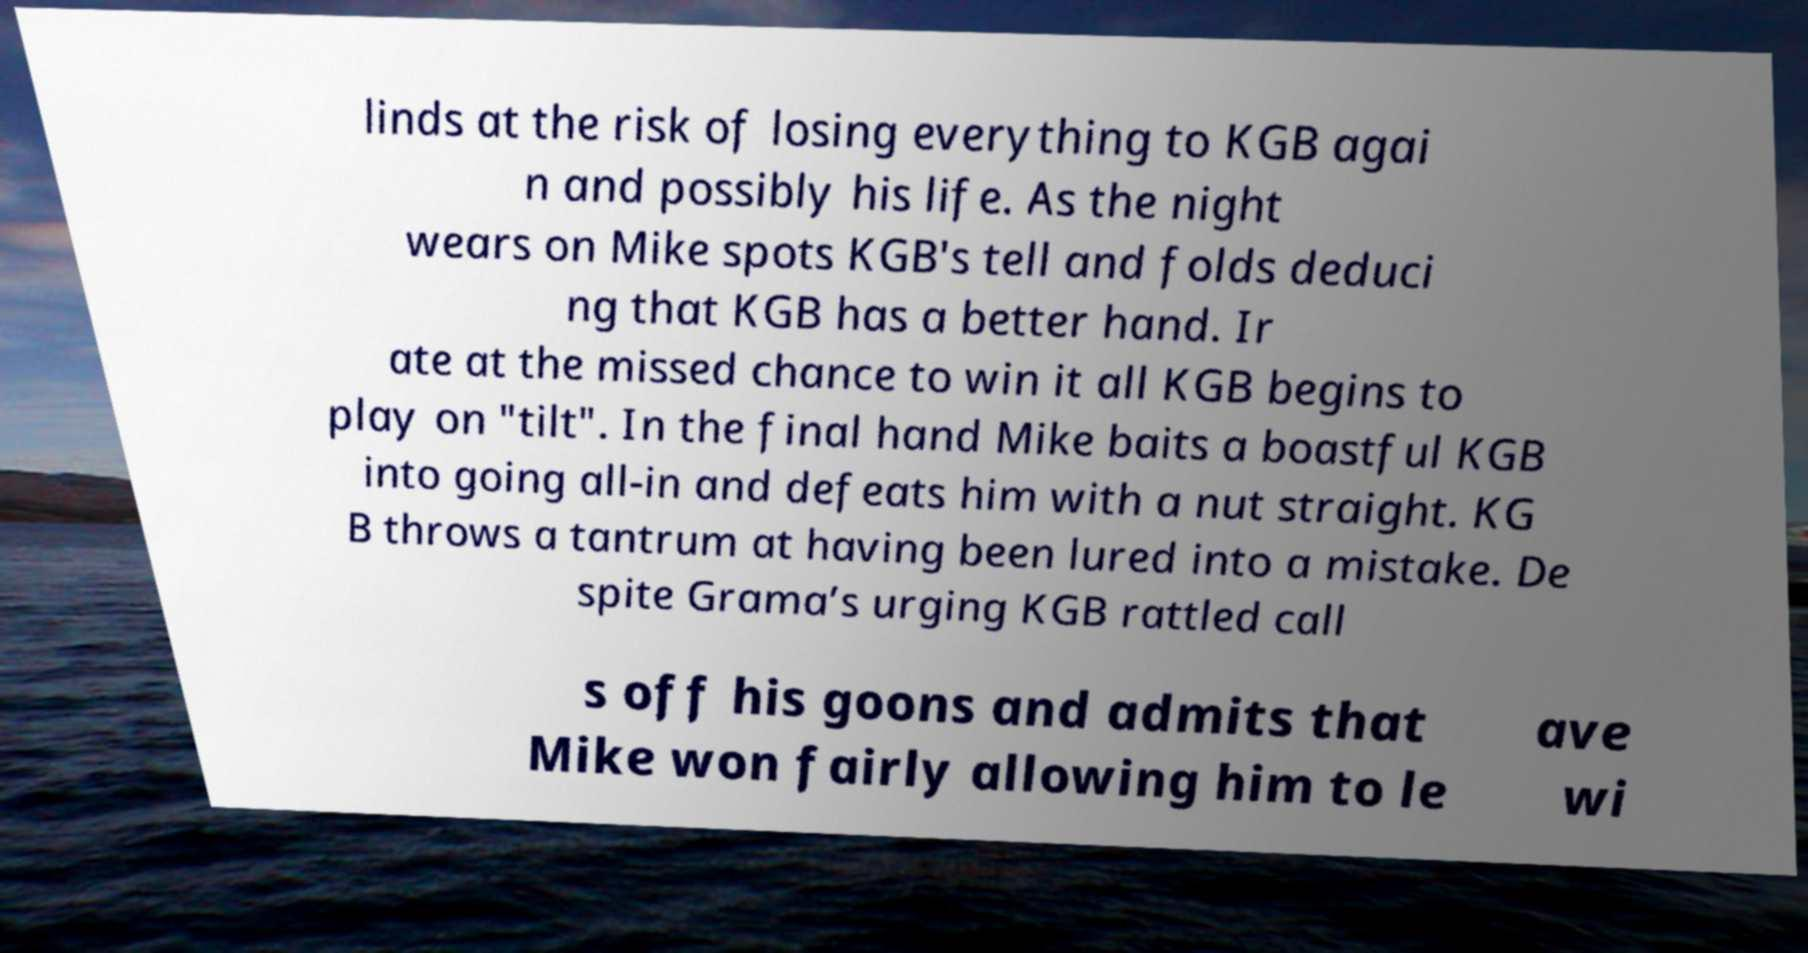What messages or text are displayed in this image? I need them in a readable, typed format. linds at the risk of losing everything to KGB agai n and possibly his life. As the night wears on Mike spots KGB's tell and folds deduci ng that KGB has a better hand. Ir ate at the missed chance to win it all KGB begins to play on "tilt". In the final hand Mike baits a boastful KGB into going all-in and defeats him with a nut straight. KG B throws a tantrum at having been lured into a mistake. De spite Grama’s urging KGB rattled call s off his goons and admits that Mike won fairly allowing him to le ave wi 